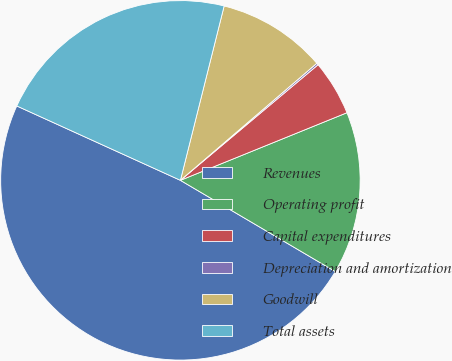Convert chart to OTSL. <chart><loc_0><loc_0><loc_500><loc_500><pie_chart><fcel>Revenues<fcel>Operating profit<fcel>Capital expenditures<fcel>Depreciation and amortization<fcel>Goodwill<fcel>Total assets<nl><fcel>48.31%<fcel>14.61%<fcel>4.98%<fcel>0.17%<fcel>9.8%<fcel>22.12%<nl></chart> 